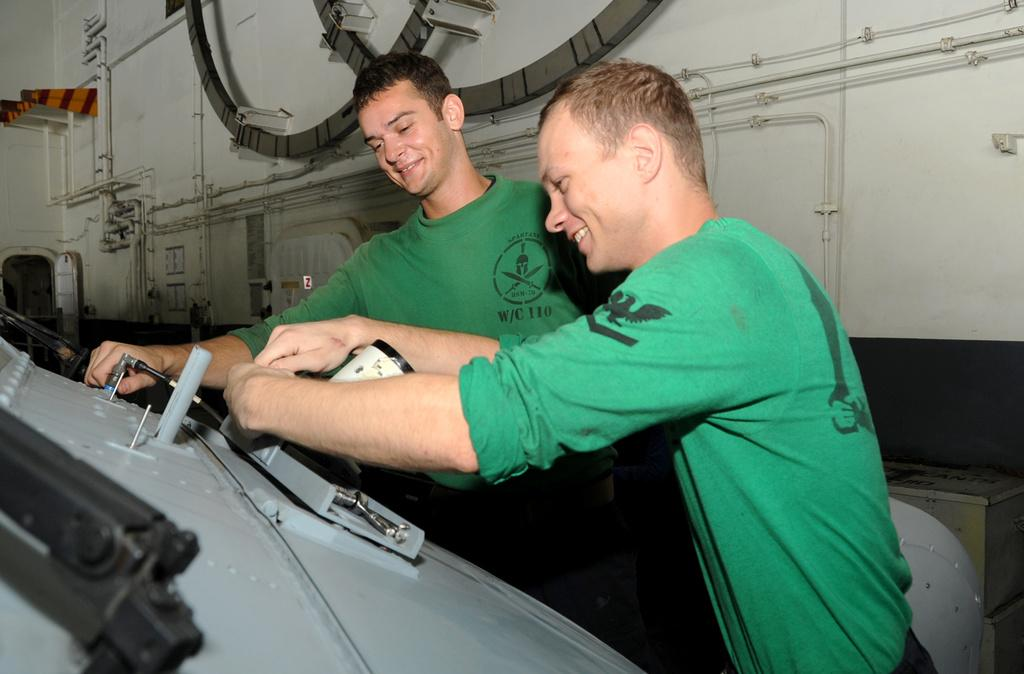How many people are in the image? There are two persons in the image. What are the two persons wearing? Both persons are wearing blue color t-shirts. What can be seen in front of the two persons? There is a machine in front of the two persons. What can be seen in the background of the image? There are pipes visible in the background of the image. Can you tell me how many owls are sitting on the machine in the image? There are no owls present in the image; it only features two persons and a machine. What type of zephyr can be seen blowing through the pipes in the background? There is no zephyr visible in the image; it only shows pipes in the background. 